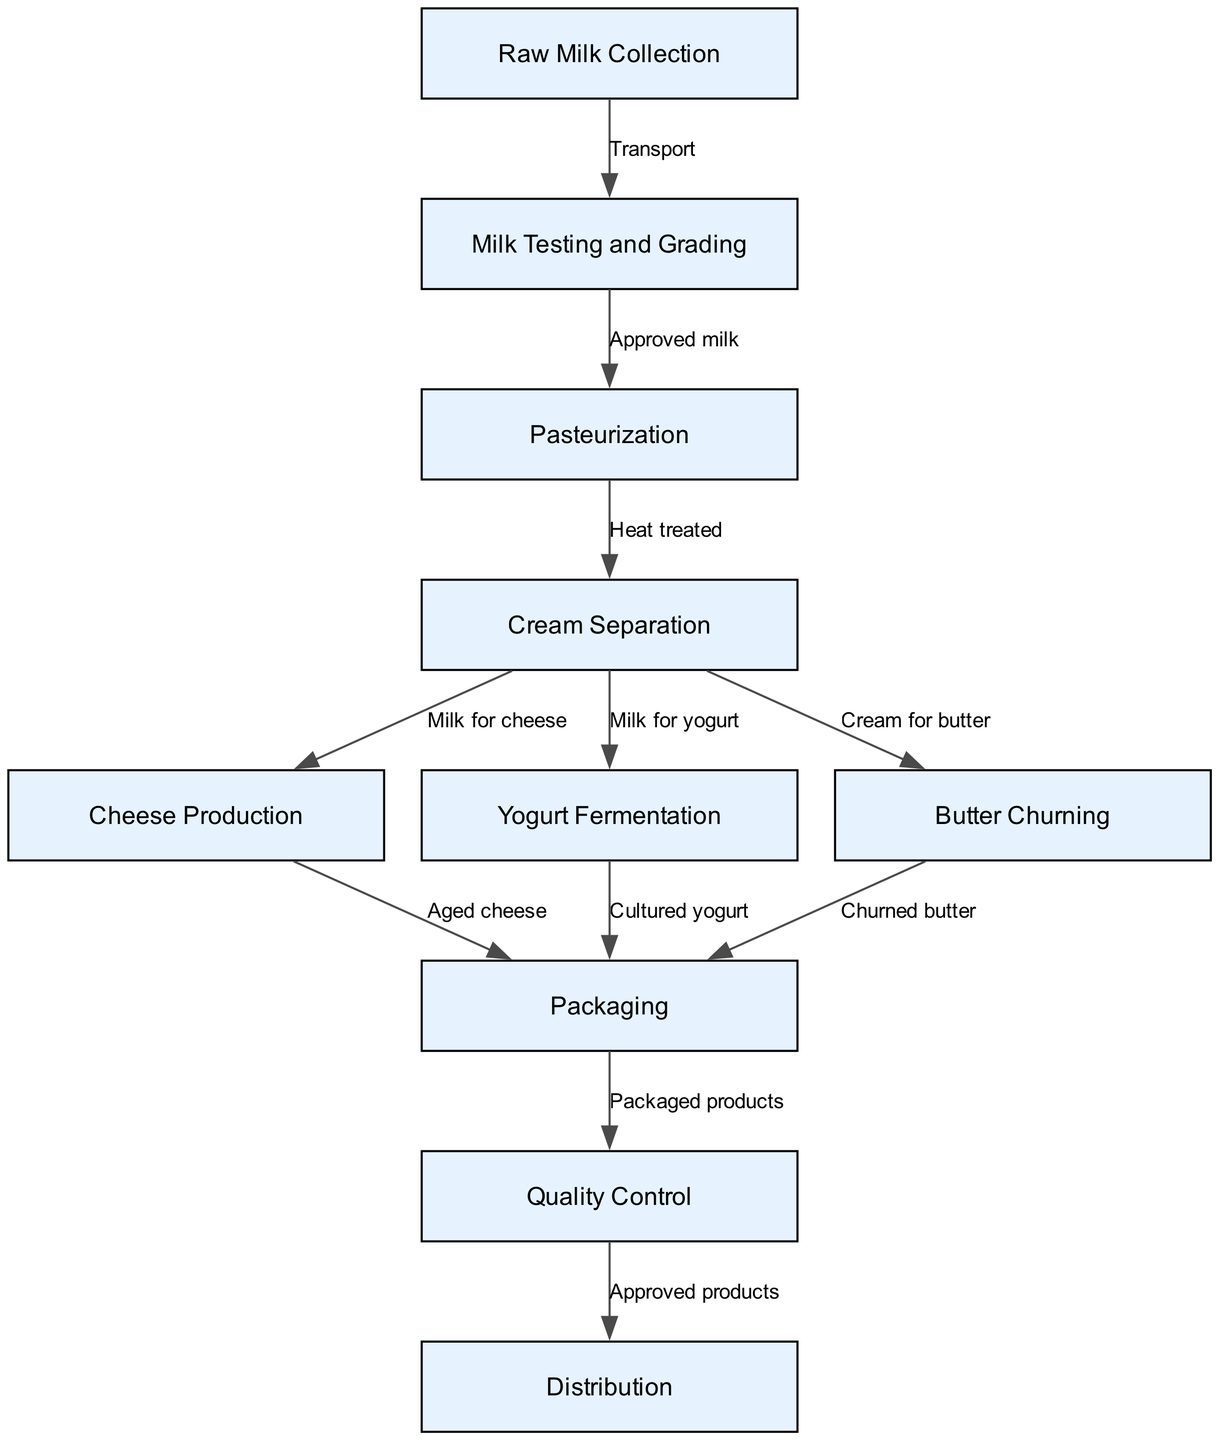What is the first step in the dairy product diversification workflow? The diagram indicates that the process begins with "Raw Milk Collection," which is the first node in the flow chart.
Answer: Raw Milk Collection How many nodes represent product packaging in the flow chart? The diagram shows a singular node labeled "Packaging," indicating that there is one specific step for this action in the workflow.
Answer: 1 Which process follows "Milk Testing and Grading" in the workflow? According to the flow chart, after the "Milk Testing and Grading," the next step connected by an edge is "Pasteurization," as indicated by the directed flow from node 2 to node 3.
Answer: Pasteurization What type of product is produced after "Cheese Production"? The diagram specifies that "Cheese Production" leads to "Packaging" with the flow indicating that the end result of this step is packaged cheese, therefore it can be referenced as the end product.
Answer: Aged cheese What is the last step before distribution in the workflow? Analyzing the flow, the last step before "Distribution" is "Quality Control," which is indicated by the connection from the packaging node to the distribution node.
Answer: Quality Control How many separate product paths emerge from "Cream Separation"? Within the workflow, "Cream Separation" gives rise to three distinct production paths: "Cheese Production," "Yogurt Fermentation," and "Butter Churning." This indicates that the output from this step can lead to multiple dairy products.
Answer: 3 Which node is responsible for the fermentation of yogurt? The diagram clearly indicates that the node labeled "Yogurt Fermentation" corresponds to the process responsible for converting milk into yogurt through fermentation processes.
Answer: Yogurt Fermentation What is the relationship between "Distribution" and "Quality Control"? According to the diagram, "Distribution" follows "Quality Control," showcasing that products go through quality checks before they are distributed to ensure that only approved products are delivered to the market.
Answer: Approved products What step comes before "Aged cheese" production in the workflow? The flow chart shows a direct path leading to "Aged cheese" from "Cheese Production," making "Cheese Production" the step immediately preceding this finished product.
Answer: Cheese Production 